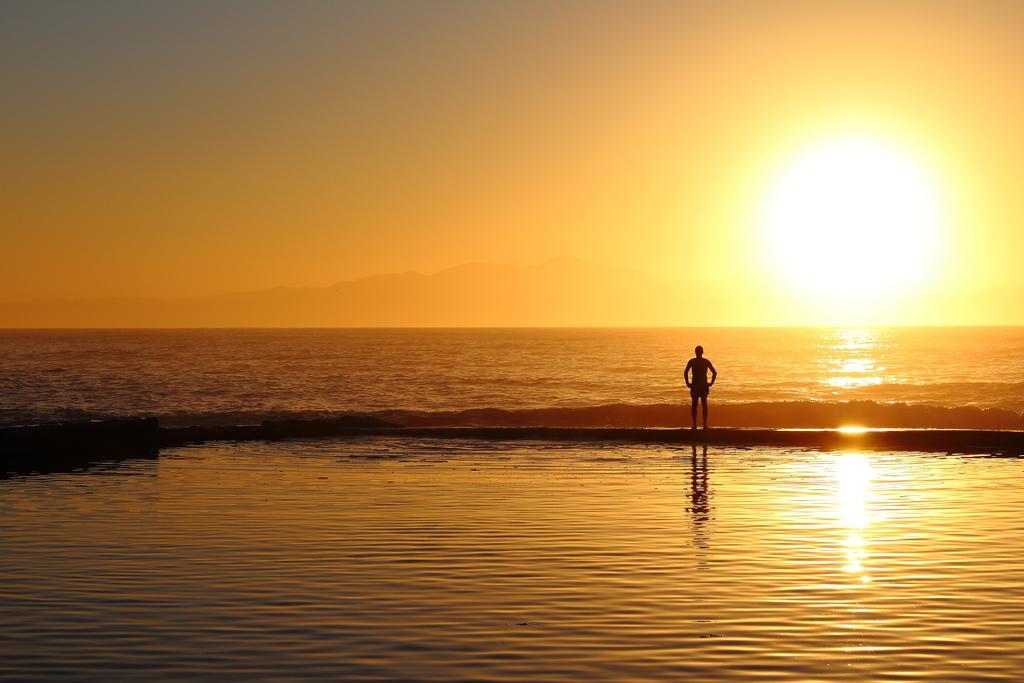Please provide a concise description of this image. In this image we can see water, a person standing here, sun, hills and the sky in the background. 